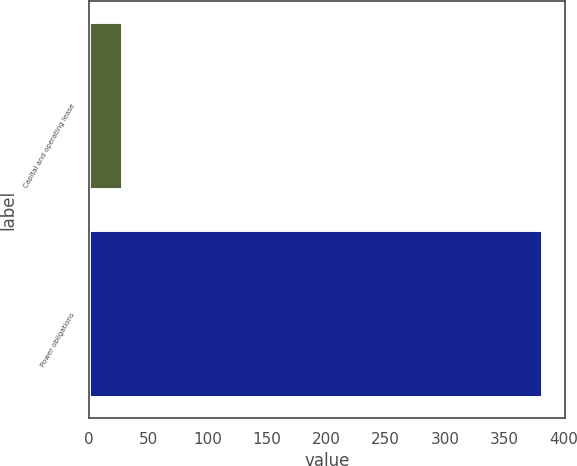Convert chart to OTSL. <chart><loc_0><loc_0><loc_500><loc_500><bar_chart><fcel>Capital and operating lease<fcel>Power obligations<nl><fcel>28<fcel>382<nl></chart> 